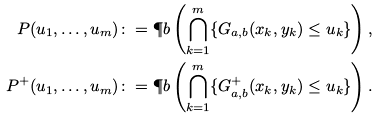<formula> <loc_0><loc_0><loc_500><loc_500>P ( u _ { 1 } , \dots , u _ { m } ) & \colon = \P b \left ( \bigcap _ { k = 1 } ^ { m } \{ G _ { a , b } ( x _ { k } , y _ { k } ) \leq u _ { k } \} \right ) , \\ P ^ { + } ( u _ { 1 } , \dots , u _ { m } ) & \colon = \P b \left ( \bigcap _ { k = 1 } ^ { m } \{ G ^ { + } _ { a , b } ( x _ { k } , y _ { k } ) \leq u _ { k } \} \right ) .</formula> 